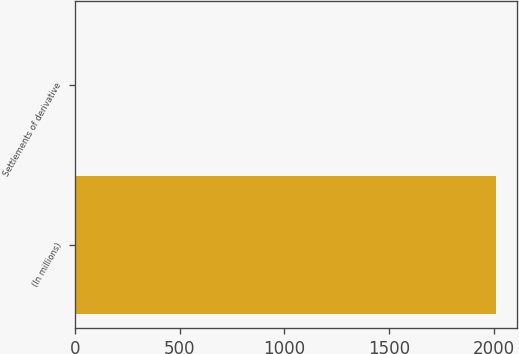<chart> <loc_0><loc_0><loc_500><loc_500><bar_chart><fcel>(In millions)<fcel>Settlements of derivative<nl><fcel>2012<fcel>2<nl></chart> 